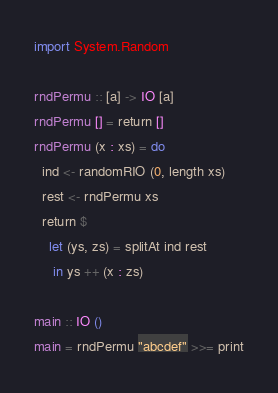<code> <loc_0><loc_0><loc_500><loc_500><_Haskell_>import System.Random

rndPermu :: [a] -> IO [a]
rndPermu [] = return []
rndPermu (x : xs) = do
  ind <- randomRIO (0, length xs)
  rest <- rndPermu xs
  return $
    let (ys, zs) = splitAt ind rest
     in ys ++ (x : zs)

main :: IO ()
main = rndPermu "abcdef" >>= print
</code> 